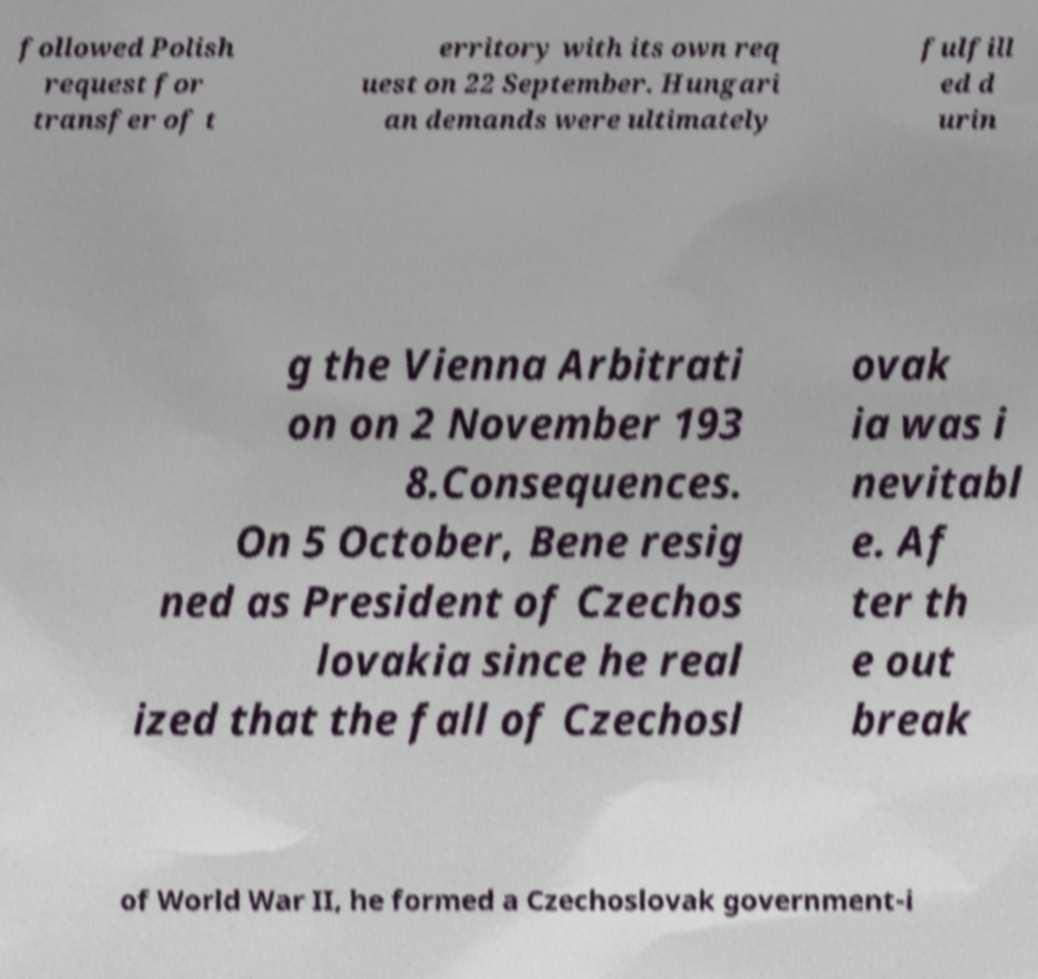Please read and relay the text visible in this image. What does it say? followed Polish request for transfer of t erritory with its own req uest on 22 September. Hungari an demands were ultimately fulfill ed d urin g the Vienna Arbitrati on on 2 November 193 8.Consequences. On 5 October, Bene resig ned as President of Czechos lovakia since he real ized that the fall of Czechosl ovak ia was i nevitabl e. Af ter th e out break of World War II, he formed a Czechoslovak government-i 